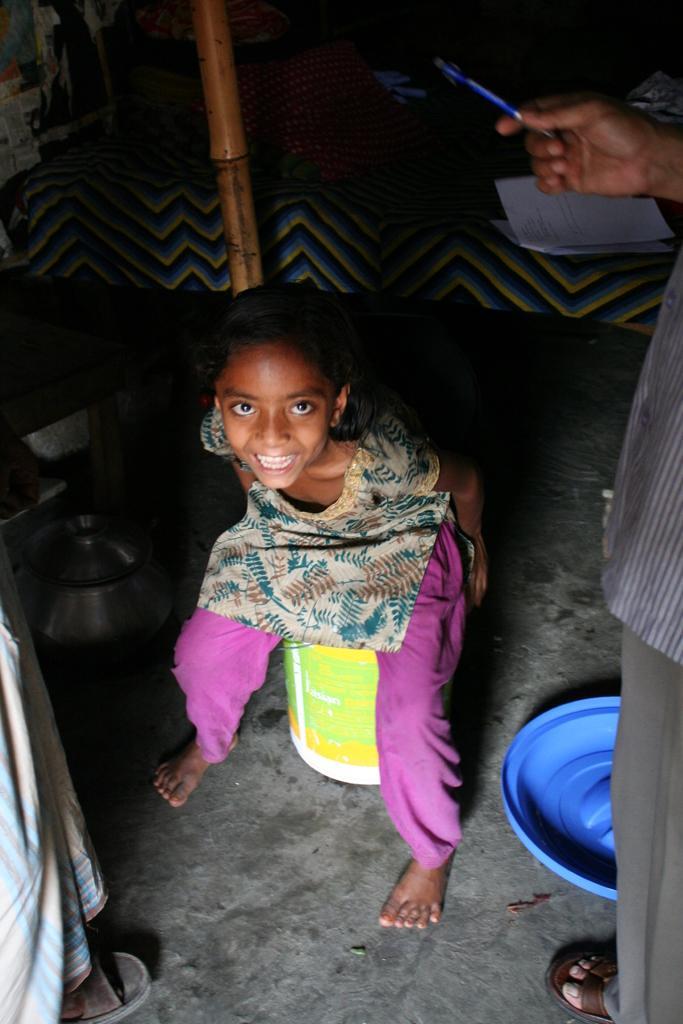Can you describe this image briefly? In this picture there is a girl sitting on the bucket and she is smiling. On the right side of the image there is a person standing and holding the pen. At the back there is a pillow and there is a book on the bed. On the left side of the image there is a person standing and at the bottom there is a bowl and there is a lid on the floor. There is a stick in the middle of the image. 